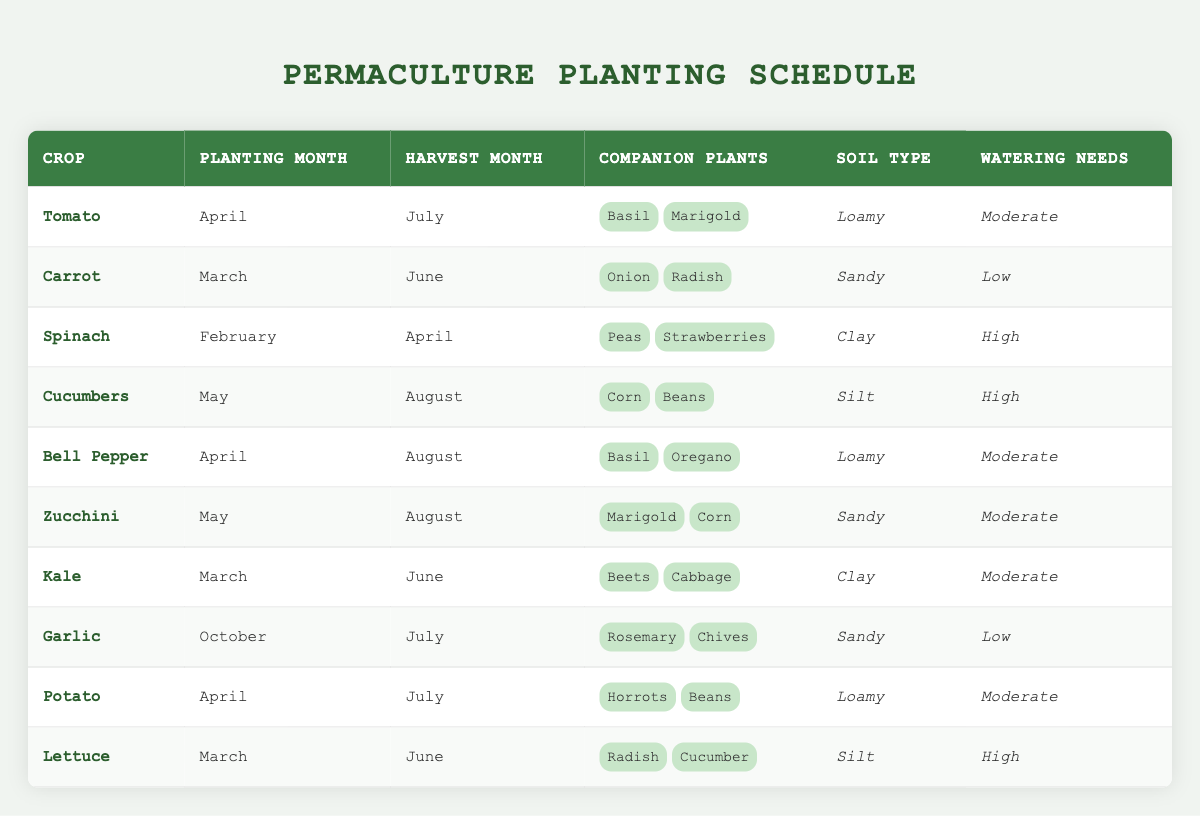What month is ideal for planting cucumbers? From the table, cucumbers should be planted in May.
Answer: May Which crops require a low watering need? The crops with low watering needs are Carrot and Garlic, both of which are listed in the table.
Answer: Carrot, Garlic How many companion plants does spinach have? Spinach has two companion plants: Peas and Strawberries, as indicated in its row.
Answer: 2 What is the harvest month for potatoes? According to the table, potatoes are harvested in July.
Answer: July Are tomatoes and bell peppers companions? The table lists basil and marigold as companions for tomatoes, and basil and oregano for bell peppers, but does not list each other as companions. Hence, they are not companions.
Answer: No What is the most common soil type among the crops in this table? By analyzing the soil types, loamy appears the most frequently (3 entries: Tomato, Bell Pepper, Potato), compared to sandy (3 entries: Carrot, Garlic, Zucchini), clay (2 entries: Spinach, Kale) and silt (2 entries: Cucumbers, Lettuce). Therefore, there is a tie between loamy and sandy.
Answer: Loamy and Sandy Which crop has the highest watering needs and what is this need? The crops with high watering needs are Spinach, Cucumbers, and Lettuce. Each of these crops requires high watering, as indicated in their respective rows.
Answer: High What is the difference in planting months between garlic and carrots? Garlic is planted in October, while carrots are planted in March. Calculating the month difference, we find October is 7 months after March.
Answer: 7 months If I wanted to pair my tomatoes with their companion plants, which crops should I look for? For tomatoes, the companion plants are basil and marigold, thus one should look for these specific crops to plant alongside tomatoes.
Answer: Basil, Marigold 